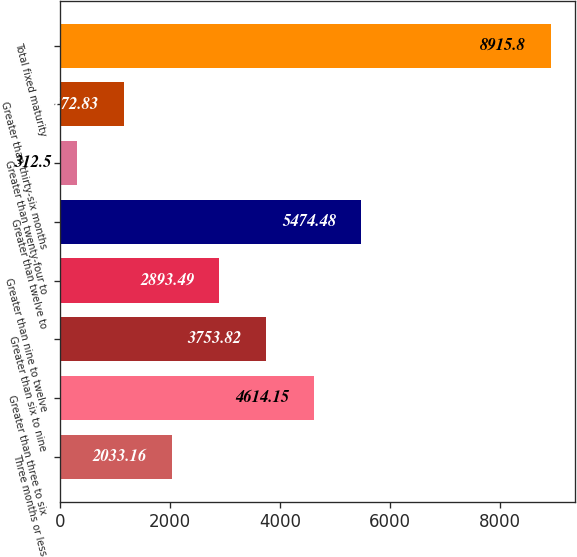<chart> <loc_0><loc_0><loc_500><loc_500><bar_chart><fcel>Three months or less<fcel>Greater than three to six<fcel>Greater than six to nine<fcel>Greater than nine to twelve<fcel>Greater than twelve to<fcel>Greater than twenty-four to<fcel>Greater than thirty-six months<fcel>Total fixed maturity<nl><fcel>2033.16<fcel>4614.15<fcel>3753.82<fcel>2893.49<fcel>5474.48<fcel>312.5<fcel>1172.83<fcel>8915.8<nl></chart> 